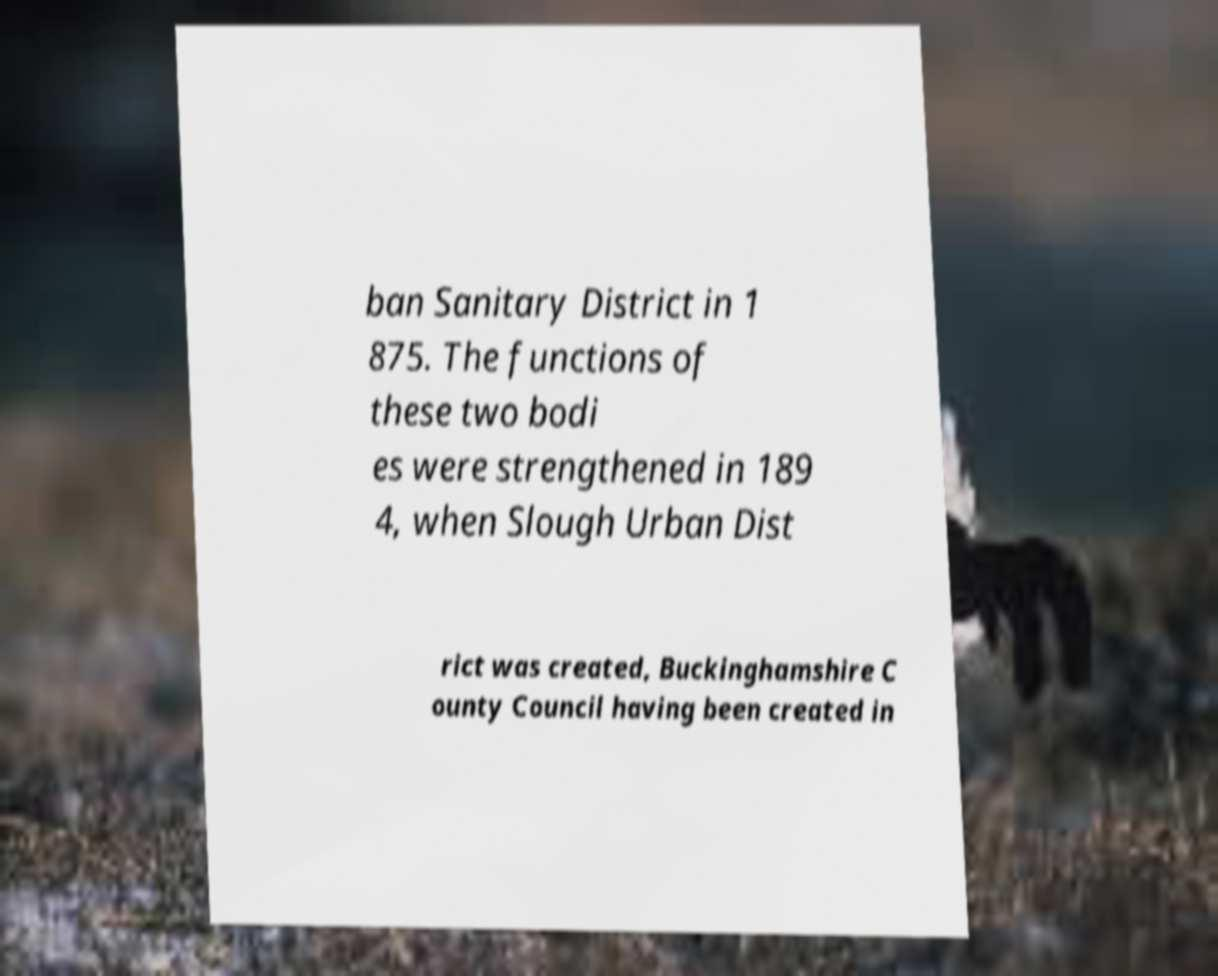There's text embedded in this image that I need extracted. Can you transcribe it verbatim? ban Sanitary District in 1 875. The functions of these two bodi es were strengthened in 189 4, when Slough Urban Dist rict was created, Buckinghamshire C ounty Council having been created in 